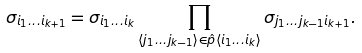Convert formula to latex. <formula><loc_0><loc_0><loc_500><loc_500>\sigma _ { i _ { 1 } \dots i _ { k + 1 } } = \sigma _ { i _ { 1 } \dots i _ { k } } \prod _ { \langle j _ { 1 } \dots j _ { k - 1 } \rangle \in \hat { p } \langle i _ { 1 } \dots i _ { k } \rangle } \sigma _ { j _ { 1 } \dots j _ { k - 1 } i _ { k + 1 } } .</formula> 